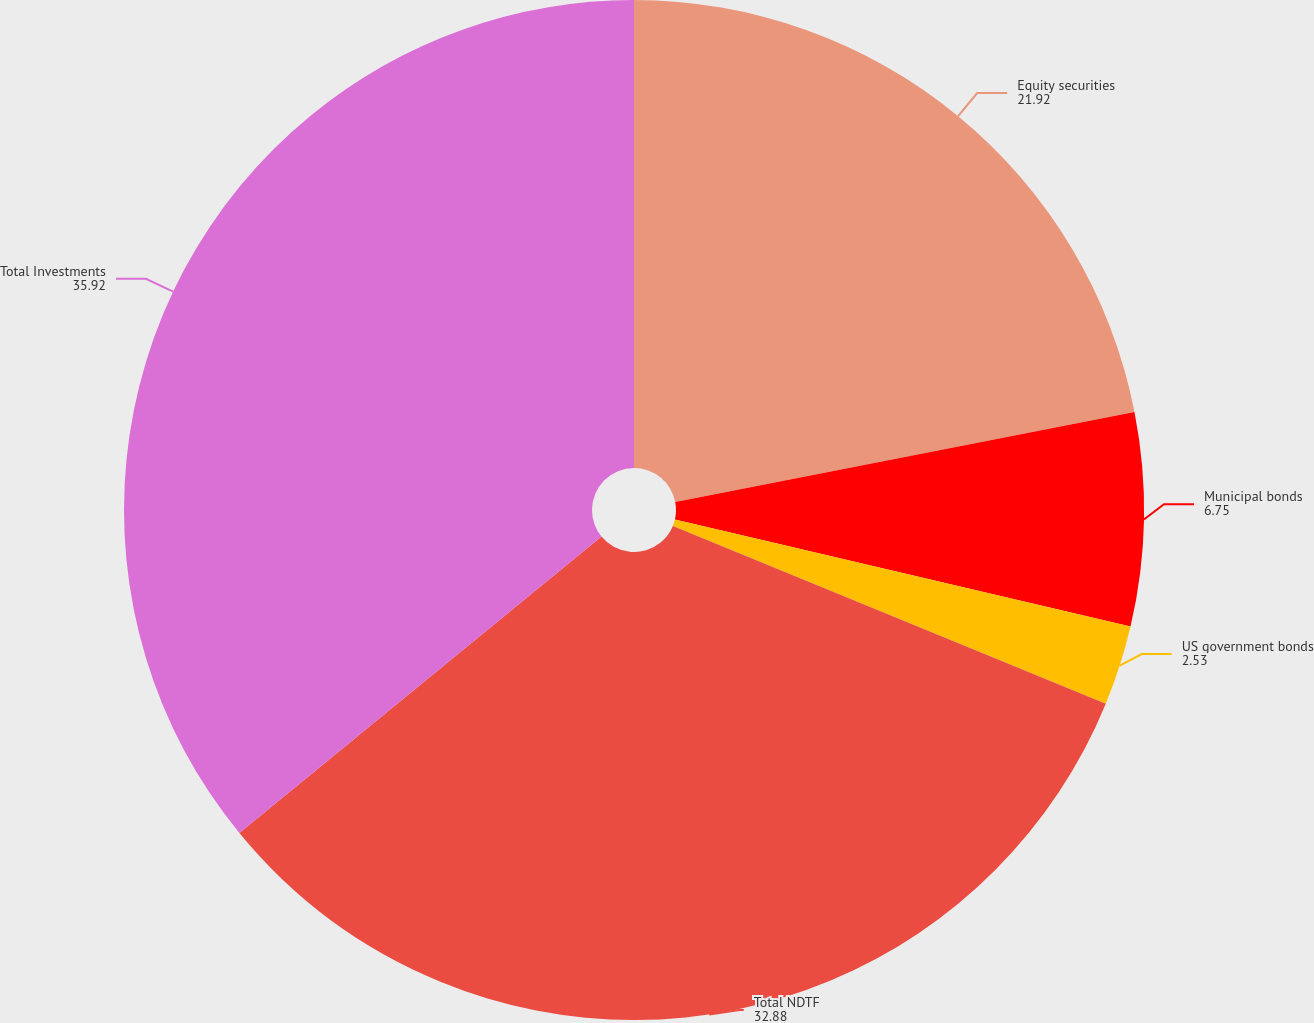<chart> <loc_0><loc_0><loc_500><loc_500><pie_chart><fcel>Equity securities<fcel>Municipal bonds<fcel>US government bonds<fcel>Total NDTF<fcel>Total Investments<nl><fcel>21.92%<fcel>6.75%<fcel>2.53%<fcel>32.88%<fcel>35.92%<nl></chart> 